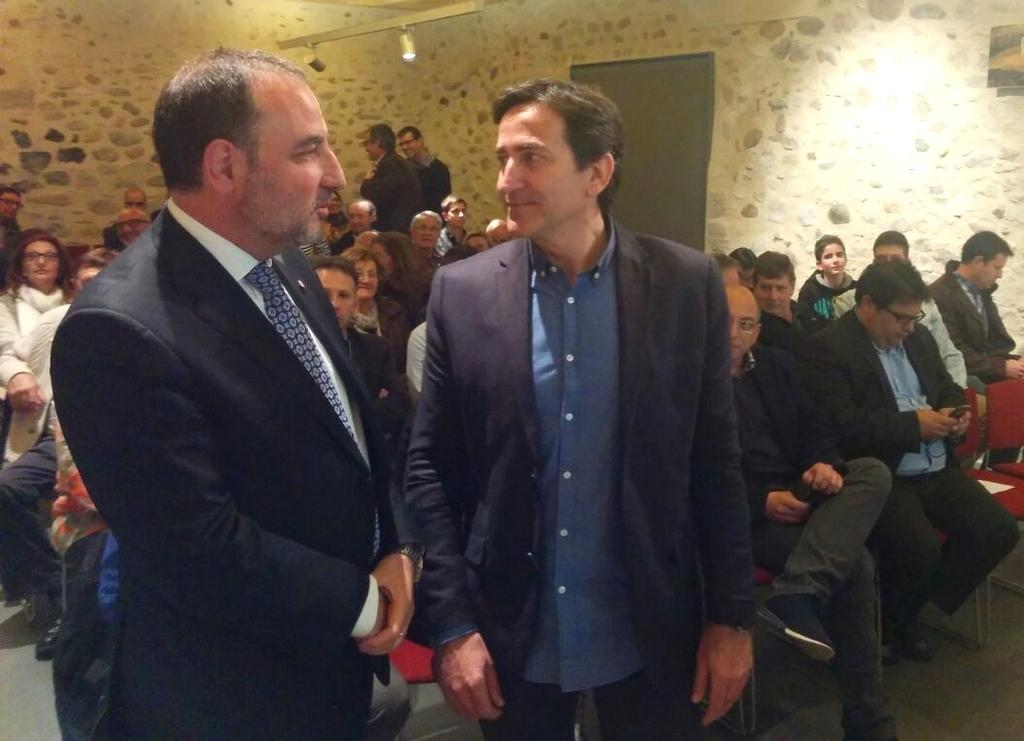How many people are in the image? There is a group of people in the image. What are some of the people in the image doing? Some people are sitting on chairs, while others are standing. What can be seen in the background of the image? There is a wall in the background of the image. Can you see any deer or horses in the image? No, there are no deer or horses present in the image. Is there any oil visible in the image? No, there is no oil visible in the image. 